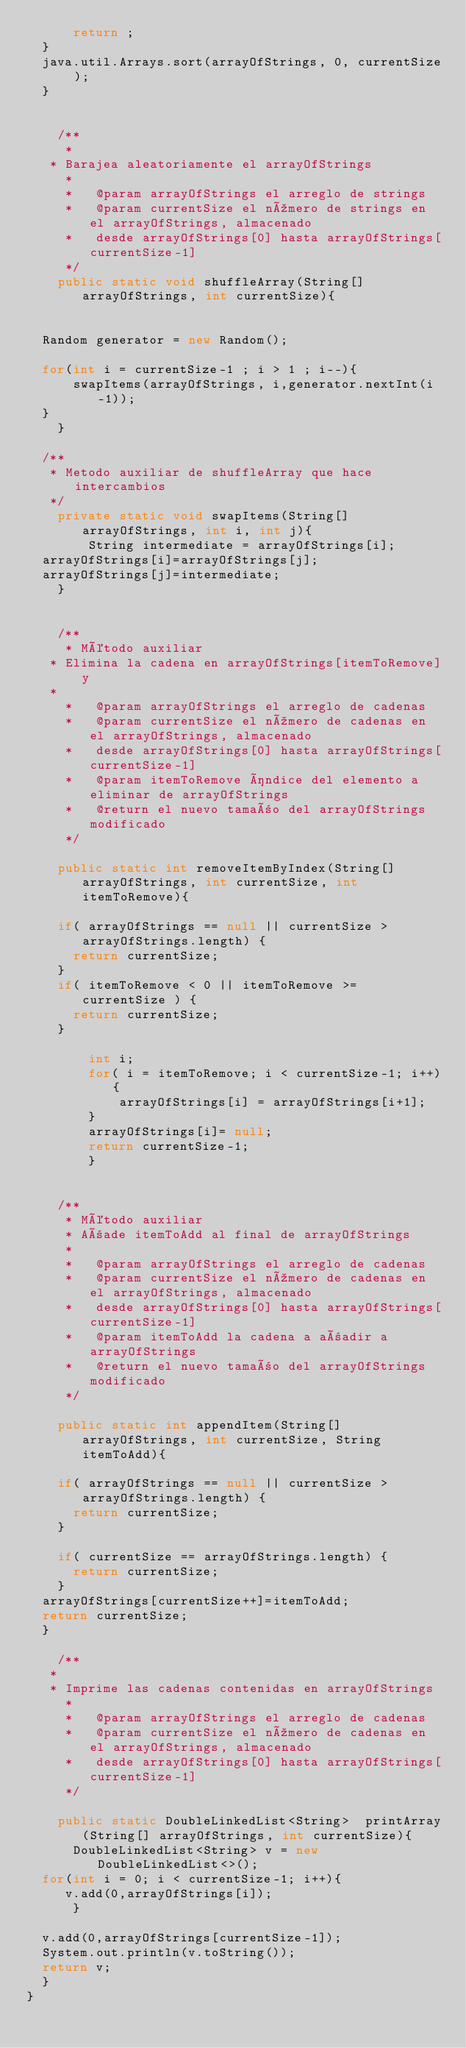<code> <loc_0><loc_0><loc_500><loc_500><_Java_>	    return ;
	}
	java.util.Arrays.sort(arrayOfStrings, 0, currentSize );
	}


    /**
     *
	 * Barajea aleatoriamente el arrayOfStrings
     *
     *   @param arrayOfStrings el arreglo de strings
     *   @param currentSize el número de strings en el arrayOfStrings, almacenado
     *   desde arrayOfStrings[0] hasta arrayOfStrings[currentSize-1]
     */
    public static void shuffleArray(String[] arrayOfStrings, int currentSize){


	Random generator = new Random();

	for(int i = currentSize-1 ; i > 1 ; i--){
	    swapItems(arrayOfStrings, i,generator.nextInt(i-1));
	}
    }

	/**
	 * Metodo auxiliar de shuffleArray que hace intercambios
	 */
    private static void swapItems(String[] arrayOfStrings, int i, int j){
        String intermediate = arrayOfStrings[i];
	arrayOfStrings[i]=arrayOfStrings[j];
	arrayOfStrings[j]=intermediate;
    }


    /**
     * Método auxiliar
	 * Elimina la cadena en arrayOfStrings[itemToRemove] y
	 *
     *   @param arrayOfStrings el arreglo de cadenas
     *   @param currentSize el número de cadenas en el arrayOfStrings, almacenado
     *   desde arrayOfStrings[0] hasta arrayOfStrings[currentSize-1]
     *   @param itemToRemove índice del elemento a eliminar de arrayOfStrings
     *   @return el nuevo tamaño del arrayOfStrings modificado
     */

    public static int removeItemByIndex(String[] arrayOfStrings, int currentSize, int itemToRemove){

		if( arrayOfStrings == null || currentSize > arrayOfStrings.length) {
			return currentSize;
		}
		if( itemToRemove < 0 || itemToRemove >= currentSize ) {
			return currentSize;
		}

        int i;
        for( i = itemToRemove; i < currentSize-1; i++){
            arrayOfStrings[i] = arrayOfStrings[i+1];
        }
        arrayOfStrings[i]= null;
        return currentSize-1;
        }


    /**
     * Método auxiliar
     * Añade itemToAdd al final de arrayOfStrings
     *
     *   @param arrayOfStrings el arreglo de cadenas
     *   @param currentSize el número de cadenas en el arrayOfStrings, almacenado
     *   desde arrayOfStrings[0] hasta arrayOfStrings[currentSize-1]
     *   @param itemToAdd la cadena a añadir a arrayOfStrings
     *   @return el nuevo tamaño del arrayOfStrings modificado
     */

    public static int appendItem(String[] arrayOfStrings, int currentSize, String itemToAdd){

		if( arrayOfStrings == null || currentSize > arrayOfStrings.length) {
			return currentSize;
		}

		if( currentSize == arrayOfStrings.length) {
			return currentSize;
		}
	arrayOfStrings[currentSize++]=itemToAdd;
	return currentSize;
	}

    /**
	 *
	 * Imprime las cadenas contenidas en arrayOfStrings
     *
     *   @param arrayOfStrings el arreglo de cadenas
     *   @param currentSize el número de cadenas en el arrayOfStrings, almacenado
     *   desde arrayOfStrings[0] hasta arrayOfStrings[currentSize-1]
     */

    public static DoubleLinkedList<String>  printArray(String[] arrayOfStrings, int currentSize){
			DoubleLinkedList<String> v = new DoubleLinkedList<>();
	for(int i = 0; i < currentSize-1; i++){
		 v.add(0,arrayOfStrings[i]);
      }

	v.add(0,arrayOfStrings[currentSize-1]);
	System.out.println(v.toString());
	return v;
	}
}
</code> 